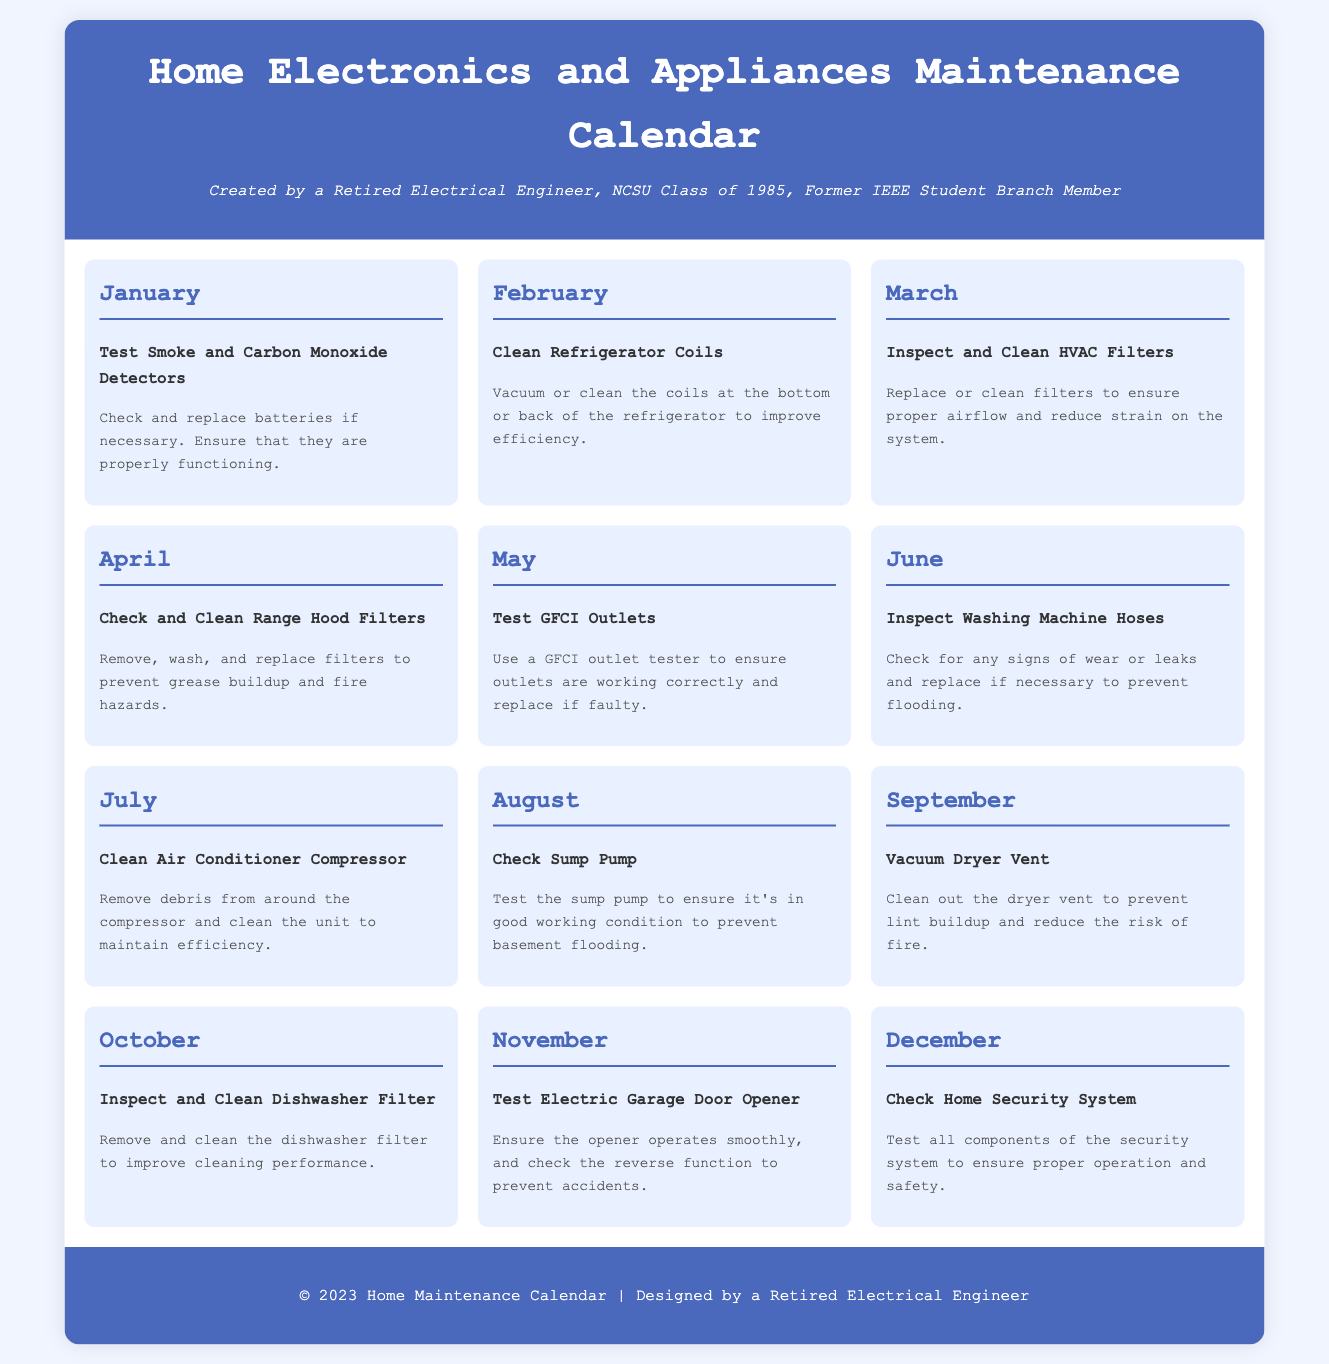what is the first maintenance task listed? The first task listed in the calendar is for January, which is to Test Smoke and Carbon Monoxide Detectors.
Answer: Test Smoke and Carbon Monoxide Detectors how many months are included in the calendar? The document provides maintenance tasks for each month of the year, which totals twelve months.
Answer: 12 what month is dedicated to cleaning refrigerator coils? The month associated with cleaning refrigerator coils is February.
Answer: February which appliance's hoses are inspected in June? The appliance whose hoses are inspected in June is the washing machine.
Answer: Washing Machine what task is scheduled for October? The maintenance task scheduled for October is to Inspect and Clean Dishwasher Filter.
Answer: Inspect and Clean Dishwasher Filter in which month should you check the sump pump? The sump pump should be checked in August.
Answer: August what is the purpose of testing GFCI outlets in May? The purpose of testing GFCI outlets in May is to ensure the outlets are working correctly and replace if faulty.
Answer: Ensure correct operation which task helps prevent basement flooding? The task that helps prevent basement flooding is to check the sump pump.
Answer: Check Sump Pump what maintenance task occurs in November? The maintenance task that occurs in November is to Test Electric Garage Door Opener.
Answer: Test Electric Garage Door Opener 